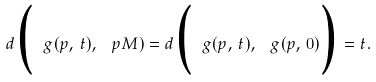Convert formula to latex. <formula><loc_0><loc_0><loc_500><loc_500>d \Big ( \ g ( p , \, t ) , \, \ p M ) = d \Big ( \ g ( p , \, t ) , \, \ g ( p , \, 0 ) \Big ) = t .</formula> 